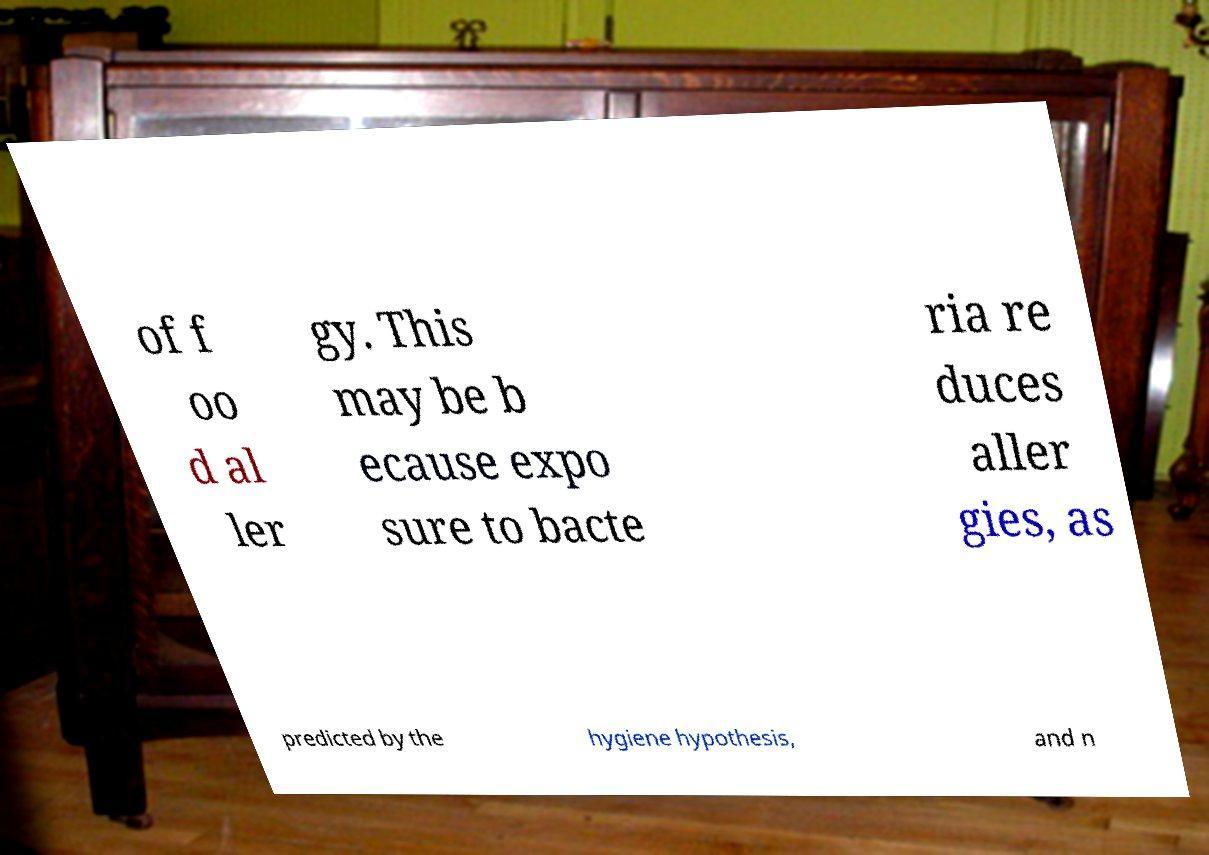Please read and relay the text visible in this image. What does it say? of f oo d al ler gy. This may be b ecause expo sure to bacte ria re duces aller gies, as predicted by the hygiene hypothesis, and n 